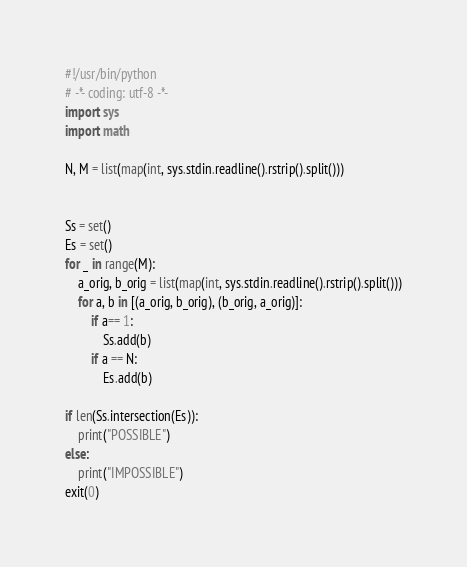Convert code to text. <code><loc_0><loc_0><loc_500><loc_500><_Python_>#!/usr/bin/python
# -*- coding: utf-8 -*-
import sys
import math

N, M = list(map(int, sys.stdin.readline().rstrip().split()))


Ss = set()
Es = set()
for _ in range(M):
    a_orig, b_orig = list(map(int, sys.stdin.readline().rstrip().split()))
    for a, b in [(a_orig, b_orig), (b_orig, a_orig)]:
        if a== 1:
            Ss.add(b)
        if a == N:
            Es.add(b)

if len(Ss.intersection(Es)):
    print("POSSIBLE")
else:
    print("IMPOSSIBLE")
exit(0)
</code> 